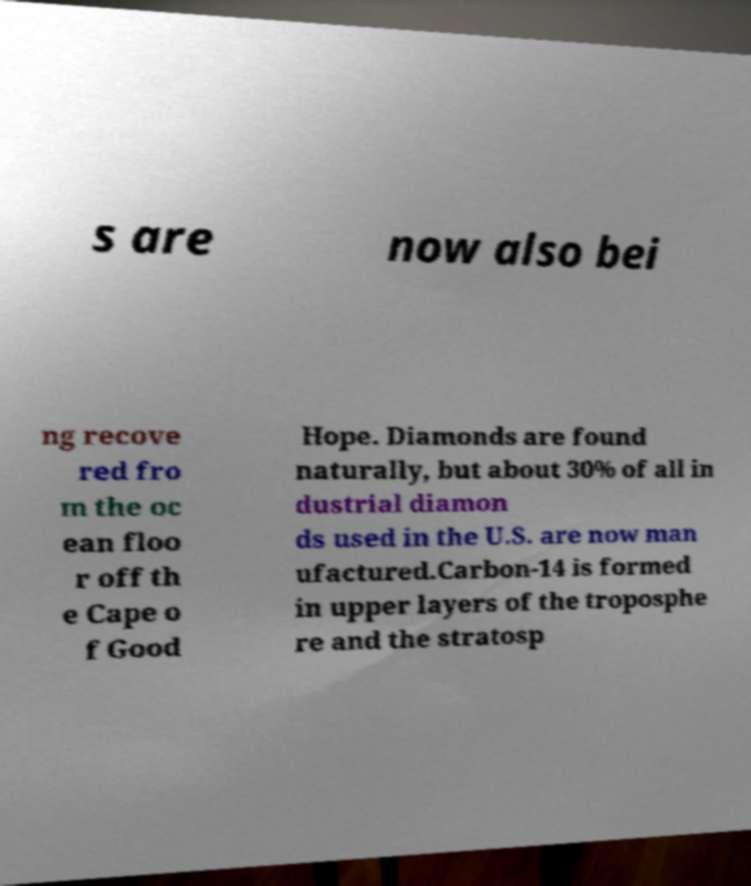Can you read and provide the text displayed in the image?This photo seems to have some interesting text. Can you extract and type it out for me? s are now also bei ng recove red fro m the oc ean floo r off th e Cape o f Good Hope. Diamonds are found naturally, but about 30% of all in dustrial diamon ds used in the U.S. are now man ufactured.Carbon-14 is formed in upper layers of the troposphe re and the stratosp 